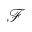Convert formula to latex. <formula><loc_0><loc_0><loc_500><loc_500>\mathcal { F }</formula> 